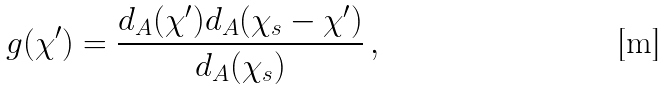<formula> <loc_0><loc_0><loc_500><loc_500>g ( \chi ^ { \prime } ) = \frac { d _ { A } ( \chi ^ { \prime } ) d _ { A } ( \chi _ { s } - \chi ^ { \prime } ) } { d _ { A } ( \chi _ { s } ) } \, ,</formula> 